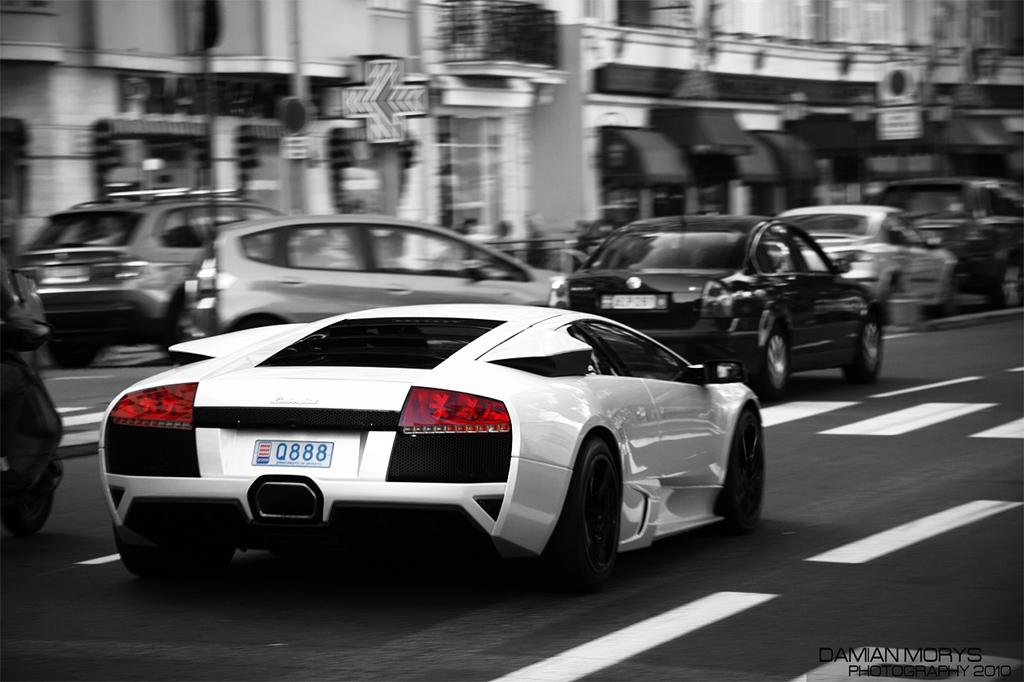What can be seen on the road in the image? There are vehicles on the road in the image. What is visible in the distance behind the vehicles? There is a building visible in the background of the image. What is placed in front of the building? There are boards in front of the building. How much dirt is present on the road in the image? There is no mention of dirt in the image, so it cannot be determined how much dirt is present. What type of lead can be seen connecting the vehicles in the image? There is no mention of any lead connecting the vehicles in the image. 